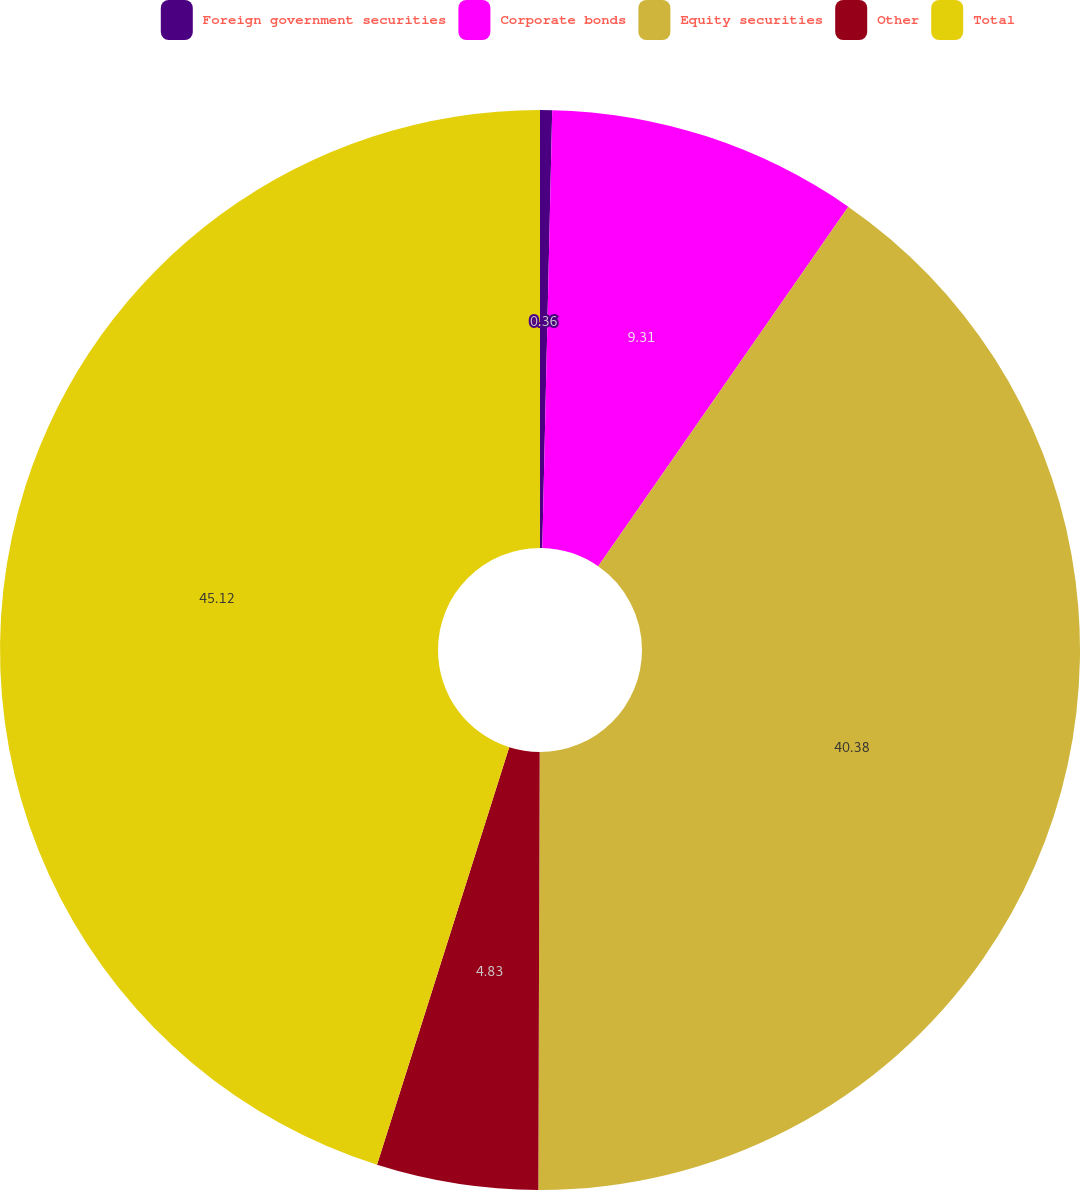<chart> <loc_0><loc_0><loc_500><loc_500><pie_chart><fcel>Foreign government securities<fcel>Corporate bonds<fcel>Equity securities<fcel>Other<fcel>Total<nl><fcel>0.36%<fcel>9.31%<fcel>40.38%<fcel>4.83%<fcel>45.12%<nl></chart> 